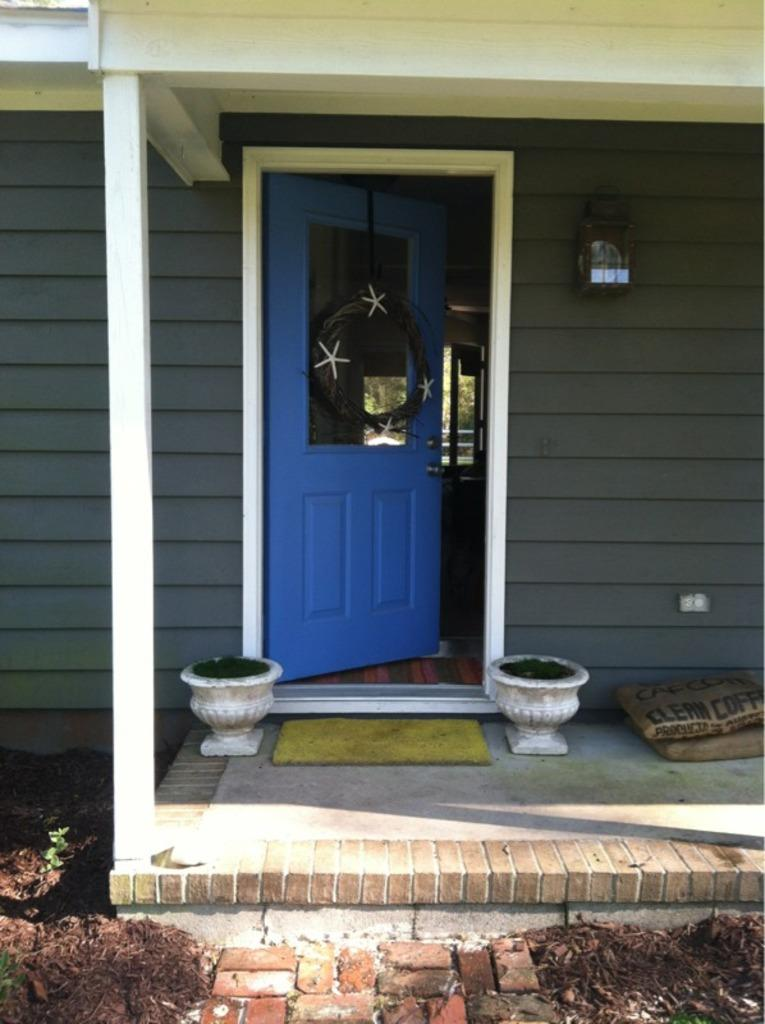What is the main feature of the image? There is an entrance to a house in the image. Are there any objects near the entrance? Yes, there are two pots near the entrance. What else can be seen beside the entrance? There is a door beside the entrance. What might belong to someone entering or exiting the house? There are two bags near the entrance. What part of the human body is visible in the image? There is no part of the human body visible in the image; it only features an entrance to a house, pots, a door, and bags. 